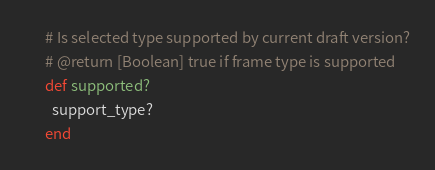<code> <loc_0><loc_0><loc_500><loc_500><_Ruby_>      # Is selected type supported by current draft version?
      # @return [Boolean] true if frame type is supported
      def supported?
        support_type?
      end
</code> 